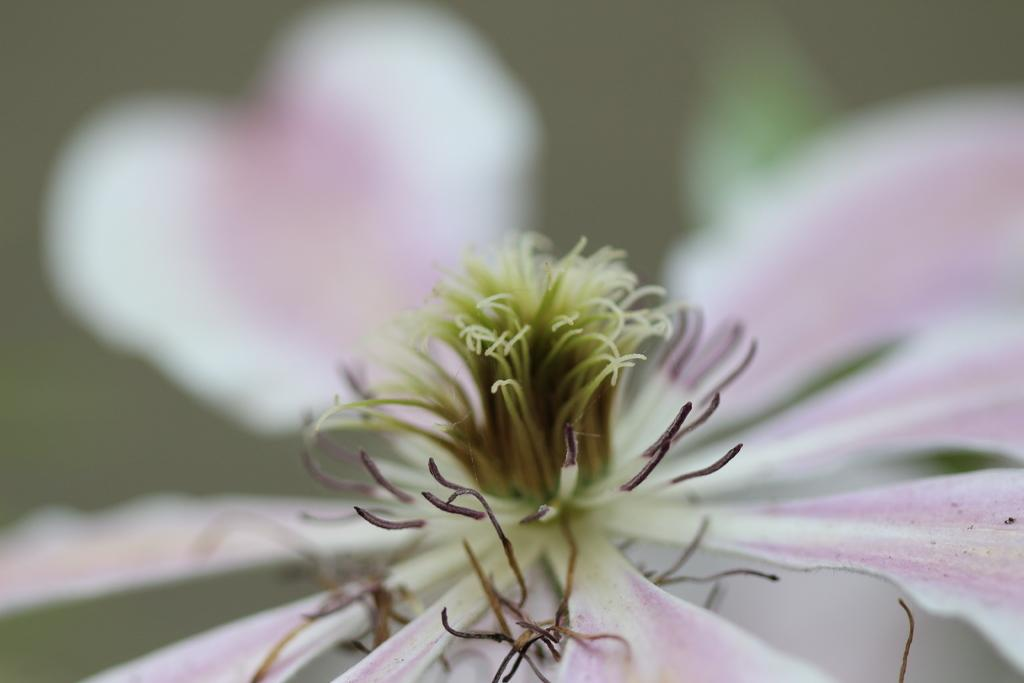What is the main subject of the image? The main subject of the image is a flower. Can you describe the color of the flower? The flower is white and pink. What is the state of the flower's petals? The petals of the flower are opened. What type of lunch is the son eating in the image? There is no son or lunch present in the image; it features a flower with white and pink petals. 